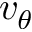Convert formula to latex. <formula><loc_0><loc_0><loc_500><loc_500>v _ { \theta }</formula> 